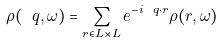Convert formula to latex. <formula><loc_0><loc_0><loc_500><loc_500>\rho ( \ q , \omega ) = \sum _ { { r } \in L \times L } e ^ { - i \ q \cdot { r } } \rho ( { r } , \omega )</formula> 